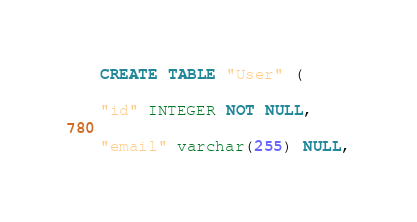<code> <loc_0><loc_0><loc_500><loc_500><_SQL_>CREATE TABLE "User" (
"id" INTEGER NOT NULL,
"email" varchar(255) NULL,</code> 